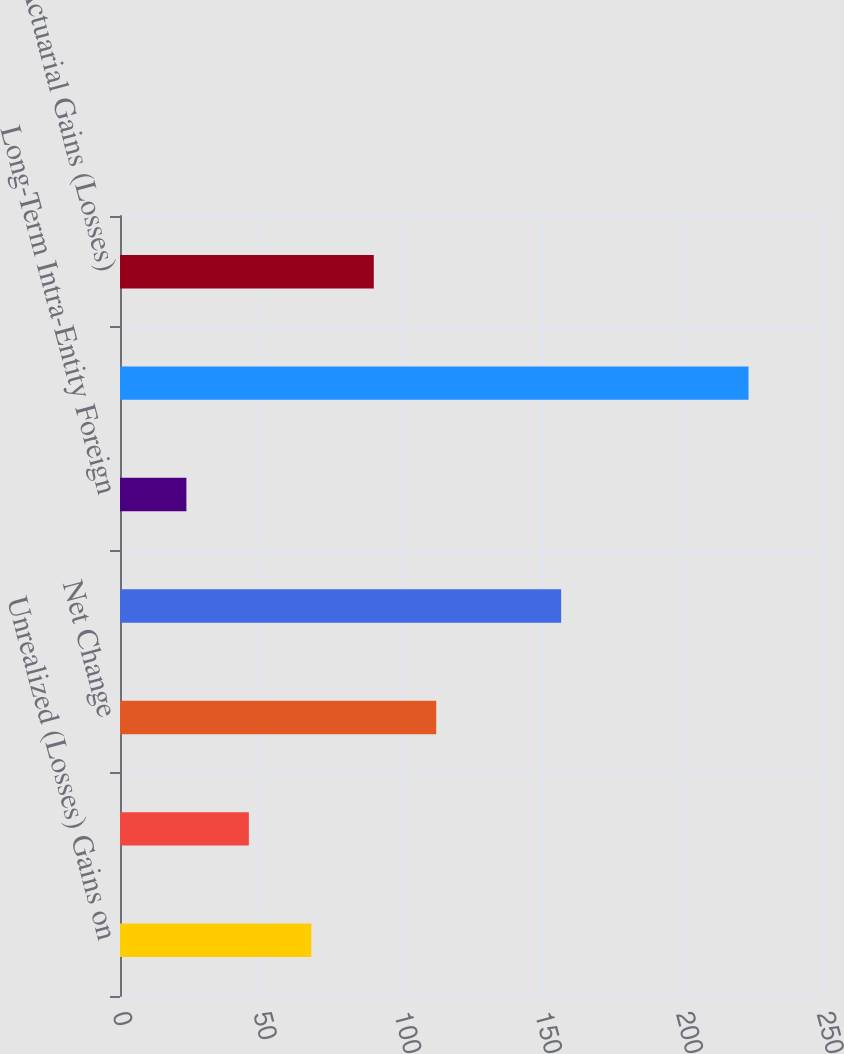Convert chart. <chart><loc_0><loc_0><loc_500><loc_500><bar_chart><fcel>Unrealized (Losses) Gains on<fcel>Reclassification Adjustment<fcel>Net Change<fcel>Foreign Currency Translation<fcel>Long-Term Intra-Entity Foreign<fcel>Net Investment Hedge Gains<fcel>Net Actuarial Gains (Losses)<nl><fcel>67.94<fcel>45.76<fcel>112.3<fcel>156.66<fcel>23.58<fcel>223.2<fcel>90.12<nl></chart> 